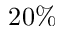Convert formula to latex. <formula><loc_0><loc_0><loc_500><loc_500>2 0 \%</formula> 